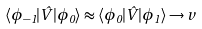<formula> <loc_0><loc_0><loc_500><loc_500>\langle \phi _ { - 1 } | \hat { V } | \phi _ { 0 } \rangle \approx \langle \phi _ { 0 } | \hat { V } | \phi _ { 1 } \rangle \to v</formula> 